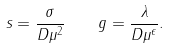Convert formula to latex. <formula><loc_0><loc_0><loc_500><loc_500>s = \frac { \sigma } { D \mu ^ { 2 } } \quad g = \frac { \lambda } { D \mu ^ { \epsilon } } .</formula> 